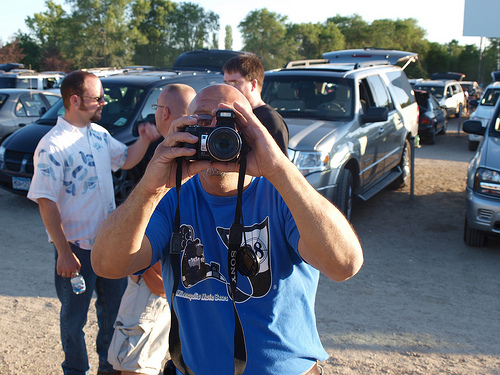<image>
Can you confirm if the camera is in front of the man? Yes. The camera is positioned in front of the man, appearing closer to the camera viewpoint. 